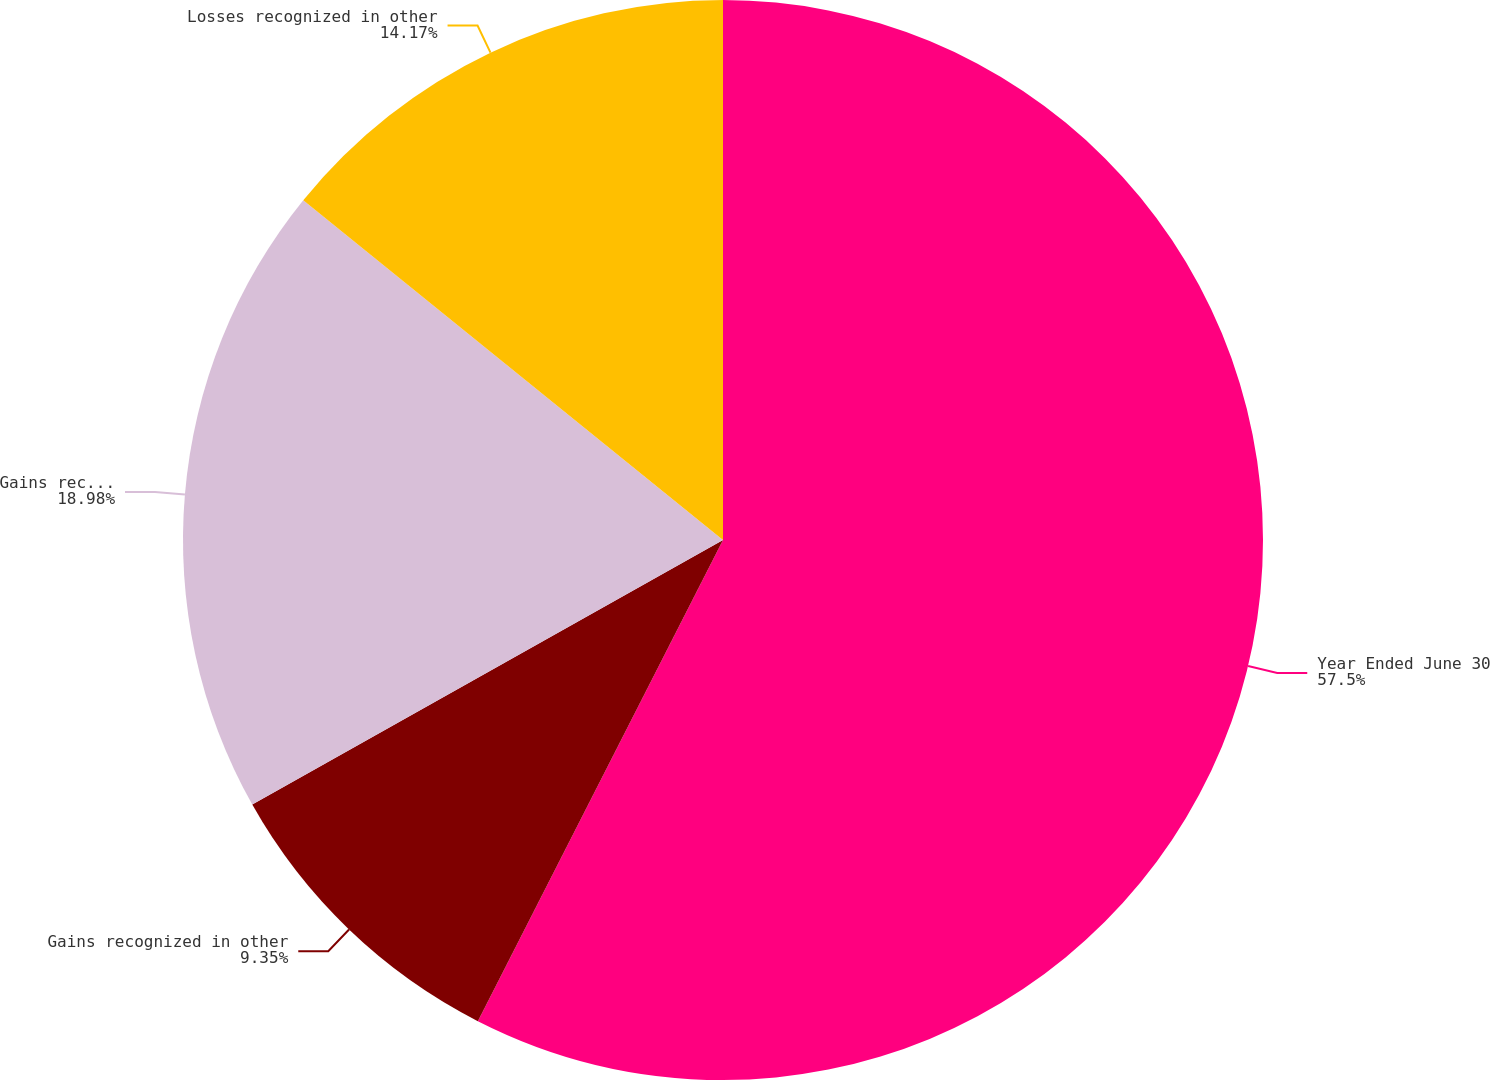Convert chart to OTSL. <chart><loc_0><loc_0><loc_500><loc_500><pie_chart><fcel>Year Ended June 30<fcel>Gains recognized in other<fcel>Gains reclassified from<fcel>Losses recognized in other<nl><fcel>57.5%<fcel>9.35%<fcel>18.98%<fcel>14.17%<nl></chart> 